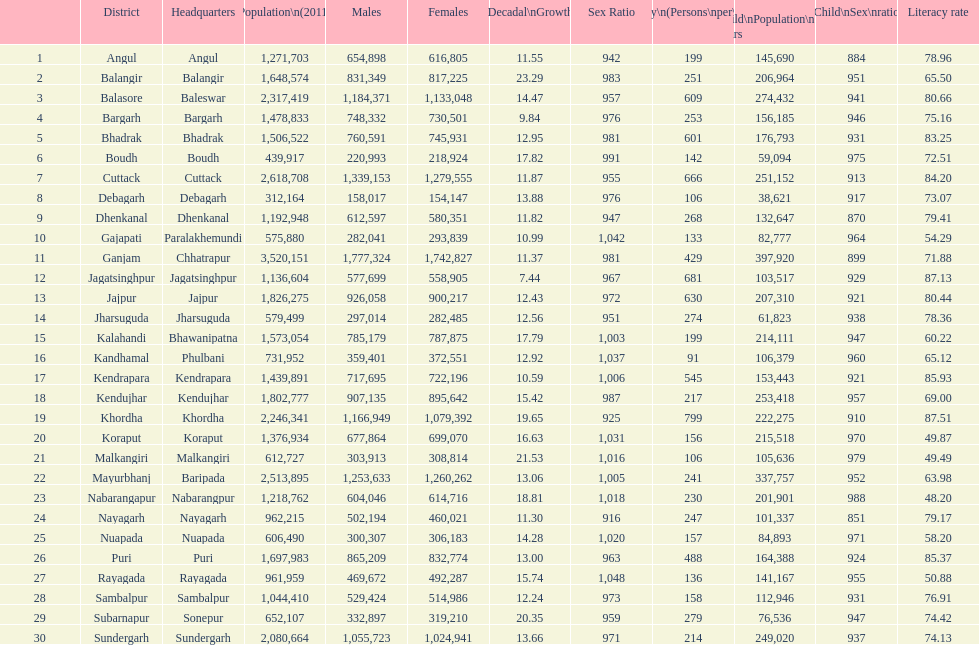Which area has a larger population, angul or cuttack? Cuttack. Could you parse the entire table? {'header': ['', 'District', 'Headquarters', 'Population\\n(2011)', 'Males', 'Females', 'Percentage\\nDecadal\\nGrowth\\n2001-2011', 'Sex Ratio', 'Density\\n(Persons\\nper\\nkm2)', 'Child\\nPopulation\\n0–6 years', 'Child\\nSex\\nratio', 'Literacy rate'], 'rows': [['1', 'Angul', 'Angul', '1,271,703', '654,898', '616,805', '11.55', '942', '199', '145,690', '884', '78.96'], ['2', 'Balangir', 'Balangir', '1,648,574', '831,349', '817,225', '23.29', '983', '251', '206,964', '951', '65.50'], ['3', 'Balasore', 'Baleswar', '2,317,419', '1,184,371', '1,133,048', '14.47', '957', '609', '274,432', '941', '80.66'], ['4', 'Bargarh', 'Bargarh', '1,478,833', '748,332', '730,501', '9.84', '976', '253', '156,185', '946', '75.16'], ['5', 'Bhadrak', 'Bhadrak', '1,506,522', '760,591', '745,931', '12.95', '981', '601', '176,793', '931', '83.25'], ['6', 'Boudh', 'Boudh', '439,917', '220,993', '218,924', '17.82', '991', '142', '59,094', '975', '72.51'], ['7', 'Cuttack', 'Cuttack', '2,618,708', '1,339,153', '1,279,555', '11.87', '955', '666', '251,152', '913', '84.20'], ['8', 'Debagarh', 'Debagarh', '312,164', '158,017', '154,147', '13.88', '976', '106', '38,621', '917', '73.07'], ['9', 'Dhenkanal', 'Dhenkanal', '1,192,948', '612,597', '580,351', '11.82', '947', '268', '132,647', '870', '79.41'], ['10', 'Gajapati', 'Paralakhemundi', '575,880', '282,041', '293,839', '10.99', '1,042', '133', '82,777', '964', '54.29'], ['11', 'Ganjam', 'Chhatrapur', '3,520,151', '1,777,324', '1,742,827', '11.37', '981', '429', '397,920', '899', '71.88'], ['12', 'Jagatsinghpur', 'Jagatsinghpur', '1,136,604', '577,699', '558,905', '7.44', '967', '681', '103,517', '929', '87.13'], ['13', 'Jajpur', 'Jajpur', '1,826,275', '926,058', '900,217', '12.43', '972', '630', '207,310', '921', '80.44'], ['14', 'Jharsuguda', 'Jharsuguda', '579,499', '297,014', '282,485', '12.56', '951', '274', '61,823', '938', '78.36'], ['15', 'Kalahandi', 'Bhawanipatna', '1,573,054', '785,179', '787,875', '17.79', '1,003', '199', '214,111', '947', '60.22'], ['16', 'Kandhamal', 'Phulbani', '731,952', '359,401', '372,551', '12.92', '1,037', '91', '106,379', '960', '65.12'], ['17', 'Kendrapara', 'Kendrapara', '1,439,891', '717,695', '722,196', '10.59', '1,006', '545', '153,443', '921', '85.93'], ['18', 'Kendujhar', 'Kendujhar', '1,802,777', '907,135', '895,642', '15.42', '987', '217', '253,418', '957', '69.00'], ['19', 'Khordha', 'Khordha', '2,246,341', '1,166,949', '1,079,392', '19.65', '925', '799', '222,275', '910', '87.51'], ['20', 'Koraput', 'Koraput', '1,376,934', '677,864', '699,070', '16.63', '1,031', '156', '215,518', '970', '49.87'], ['21', 'Malkangiri', 'Malkangiri', '612,727', '303,913', '308,814', '21.53', '1,016', '106', '105,636', '979', '49.49'], ['22', 'Mayurbhanj', 'Baripada', '2,513,895', '1,253,633', '1,260,262', '13.06', '1,005', '241', '337,757', '952', '63.98'], ['23', 'Nabarangapur', 'Nabarangpur', '1,218,762', '604,046', '614,716', '18.81', '1,018', '230', '201,901', '988', '48.20'], ['24', 'Nayagarh', 'Nayagarh', '962,215', '502,194', '460,021', '11.30', '916', '247', '101,337', '851', '79.17'], ['25', 'Nuapada', 'Nuapada', '606,490', '300,307', '306,183', '14.28', '1,020', '157', '84,893', '971', '58.20'], ['26', 'Puri', 'Puri', '1,697,983', '865,209', '832,774', '13.00', '963', '488', '164,388', '924', '85.37'], ['27', 'Rayagada', 'Rayagada', '961,959', '469,672', '492,287', '15.74', '1,048', '136', '141,167', '955', '50.88'], ['28', 'Sambalpur', 'Sambalpur', '1,044,410', '529,424', '514,986', '12.24', '973', '158', '112,946', '931', '76.91'], ['29', 'Subarnapur', 'Sonepur', '652,107', '332,897', '319,210', '20.35', '959', '279', '76,536', '947', '74.42'], ['30', 'Sundergarh', 'Sundergarh', '2,080,664', '1,055,723', '1,024,941', '13.66', '971', '214', '249,020', '937', '74.13']]} 